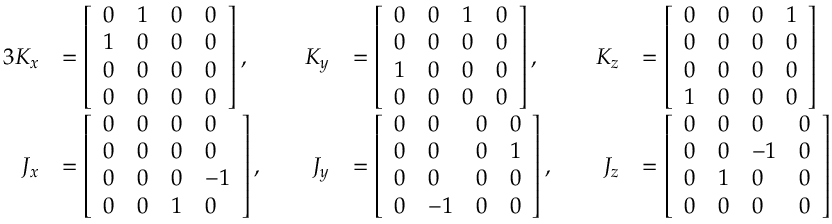<formula> <loc_0><loc_0><loc_500><loc_500>{ \begin{array} { r l r l r l } { { 3 } K _ { x } } & { = { \left [ \begin{array} { l l l l } { 0 } & { 1 } & { 0 } & { 0 } \\ { 1 } & { 0 } & { 0 } & { 0 } \\ { 0 } & { 0 } & { 0 } & { 0 } \\ { 0 } & { 0 } & { 0 } & { 0 } \end{array} \right ] } \, , \quad } & { K _ { y } } & { = { \left [ \begin{array} { l l l l } { 0 } & { 0 } & { 1 } & { 0 } \\ { 0 } & { 0 } & { 0 } & { 0 } \\ { 1 } & { 0 } & { 0 } & { 0 } \\ { 0 } & { 0 } & { 0 } & { 0 } \end{array} \right ] } \, , \quad } & { K _ { z } } & { = { \left [ \begin{array} { l l l l } { 0 } & { 0 } & { 0 } & { 1 } \\ { 0 } & { 0 } & { 0 } & { 0 } \\ { 0 } & { 0 } & { 0 } & { 0 } \\ { 1 } & { 0 } & { 0 } & { 0 } \end{array} \right ] } } \\ { J _ { x } } & { = { \left [ \begin{array} { l l l l } { 0 } & { 0 } & { 0 } & { 0 } \\ { 0 } & { 0 } & { 0 } & { 0 } \\ { 0 } & { 0 } & { 0 } & { - 1 } \\ { 0 } & { 0 } & { 1 } & { 0 } \end{array} \right ] } \, , \quad } & { J _ { y } } & { = { \left [ \begin{array} { l l l l } { 0 } & { 0 } & { 0 } & { 0 } \\ { 0 } & { 0 } & { 0 } & { 1 } \\ { 0 } & { 0 } & { 0 } & { 0 } \\ { 0 } & { - 1 } & { 0 } & { 0 } \end{array} \right ] } \, , \quad } & { J _ { z } } & { = { \left [ \begin{array} { l l l l } { 0 } & { 0 } & { 0 } & { 0 } \\ { 0 } & { 0 } & { - 1 } & { 0 } \\ { 0 } & { 1 } & { 0 } & { 0 } \\ { 0 } & { 0 } & { 0 } & { 0 } \end{array} \right ] } } \end{array} }</formula> 